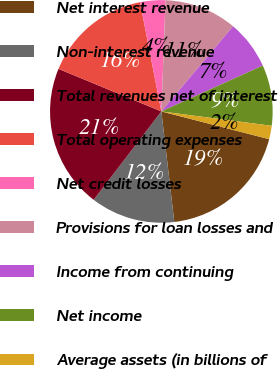Convert chart to OTSL. <chart><loc_0><loc_0><loc_500><loc_500><pie_chart><fcel>Net interest revenue<fcel>Non-interest revenue<fcel>Total revenues net of interest<fcel>Total operating expenses<fcel>Net credit losses<fcel>Provisions for loan losses and<fcel>Income from continuing<fcel>Net income<fcel>Average assets (in billions of<nl><fcel>19.13%<fcel>12.26%<fcel>20.84%<fcel>15.69%<fcel>3.67%<fcel>10.54%<fcel>7.1%<fcel>8.82%<fcel>1.95%<nl></chart> 